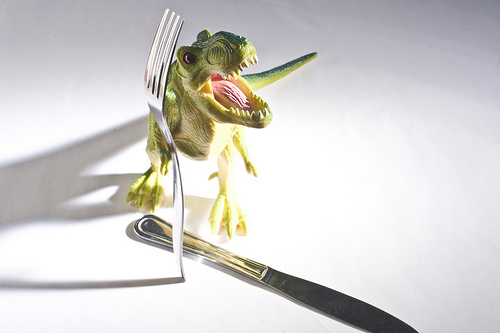<image>
Can you confirm if the dinosaur is behind the knife? Yes. From this viewpoint, the dinosaur is positioned behind the knife, with the knife partially or fully occluding the dinosaur. Where is the fork in relation to the dinosaur? Is it behind the dinosaur? No. The fork is not behind the dinosaur. From this viewpoint, the fork appears to be positioned elsewhere in the scene. Where is the fork in relation to the dinosaur? Is it in front of the dinosaur? Yes. The fork is positioned in front of the dinosaur, appearing closer to the camera viewpoint. Where is the fork in relation to the knife? Is it above the knife? Yes. The fork is positioned above the knife in the vertical space, higher up in the scene. 